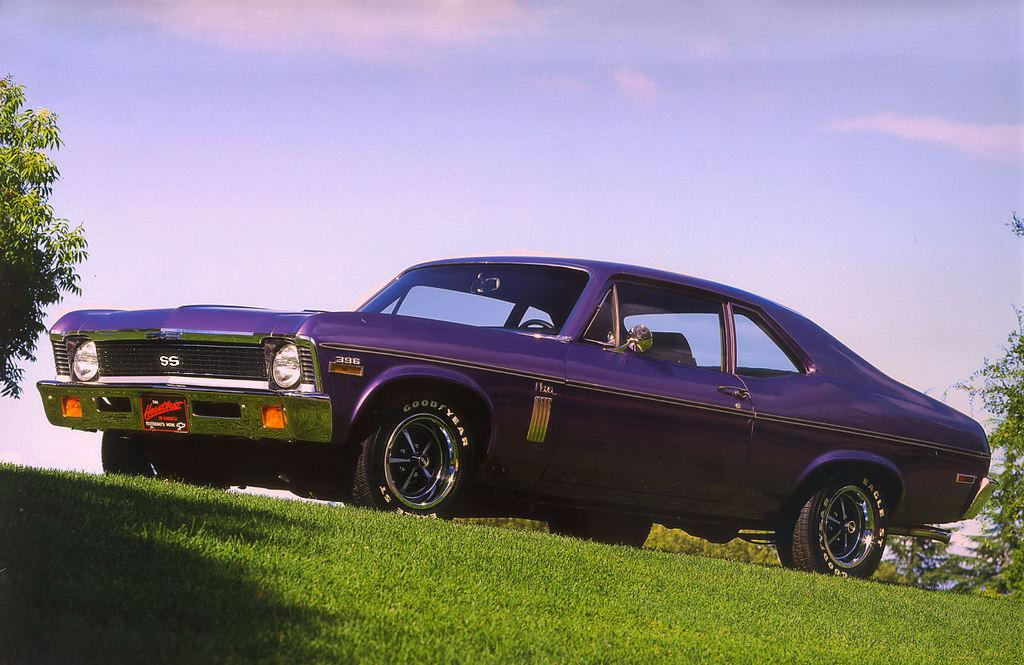What is the main subject of the image? There is a car in the image. What can be seen near the car? There are trees near the car. What type of vegetation is on the ground? There is grass on the ground. What is visible in the background of the image? The sky is visible in the background. Can you find the receipt for the car in the image? There is no receipt present in the image; it only shows a car, trees, grass, and the sky. 